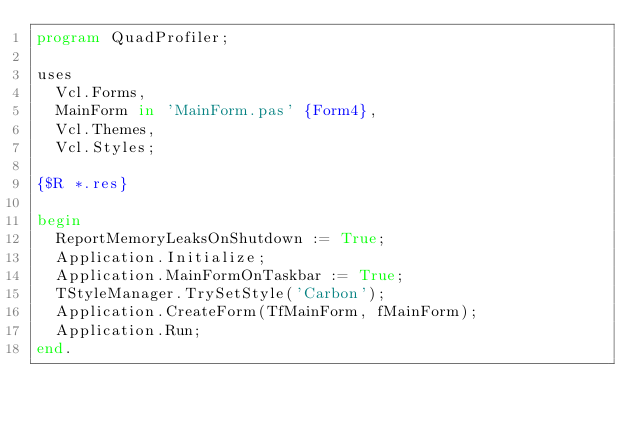<code> <loc_0><loc_0><loc_500><loc_500><_Pascal_>program QuadProfiler;

uses
  Vcl.Forms,
  MainForm in 'MainForm.pas' {Form4},
  Vcl.Themes,
  Vcl.Styles;

{$R *.res}

begin
  ReportMemoryLeaksOnShutdown := True;
  Application.Initialize;
  Application.MainFormOnTaskbar := True;
  TStyleManager.TrySetStyle('Carbon');
  Application.CreateForm(TfMainForm, fMainForm);
  Application.Run;
end.
</code> 